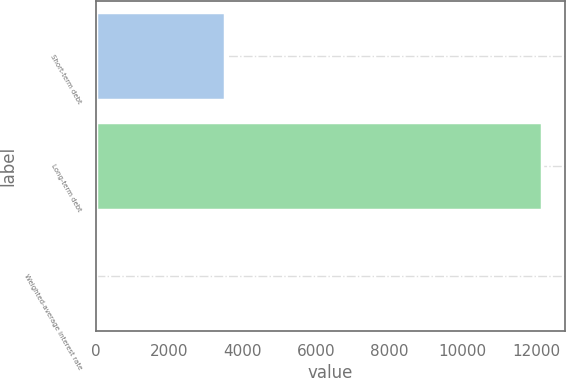Convert chart to OTSL. <chart><loc_0><loc_0><loc_500><loc_500><bar_chart><fcel>Short-term debt<fcel>Long-term debt<fcel>Weighted-average interest rate<nl><fcel>3525<fcel>12168<fcel>3.4<nl></chart> 